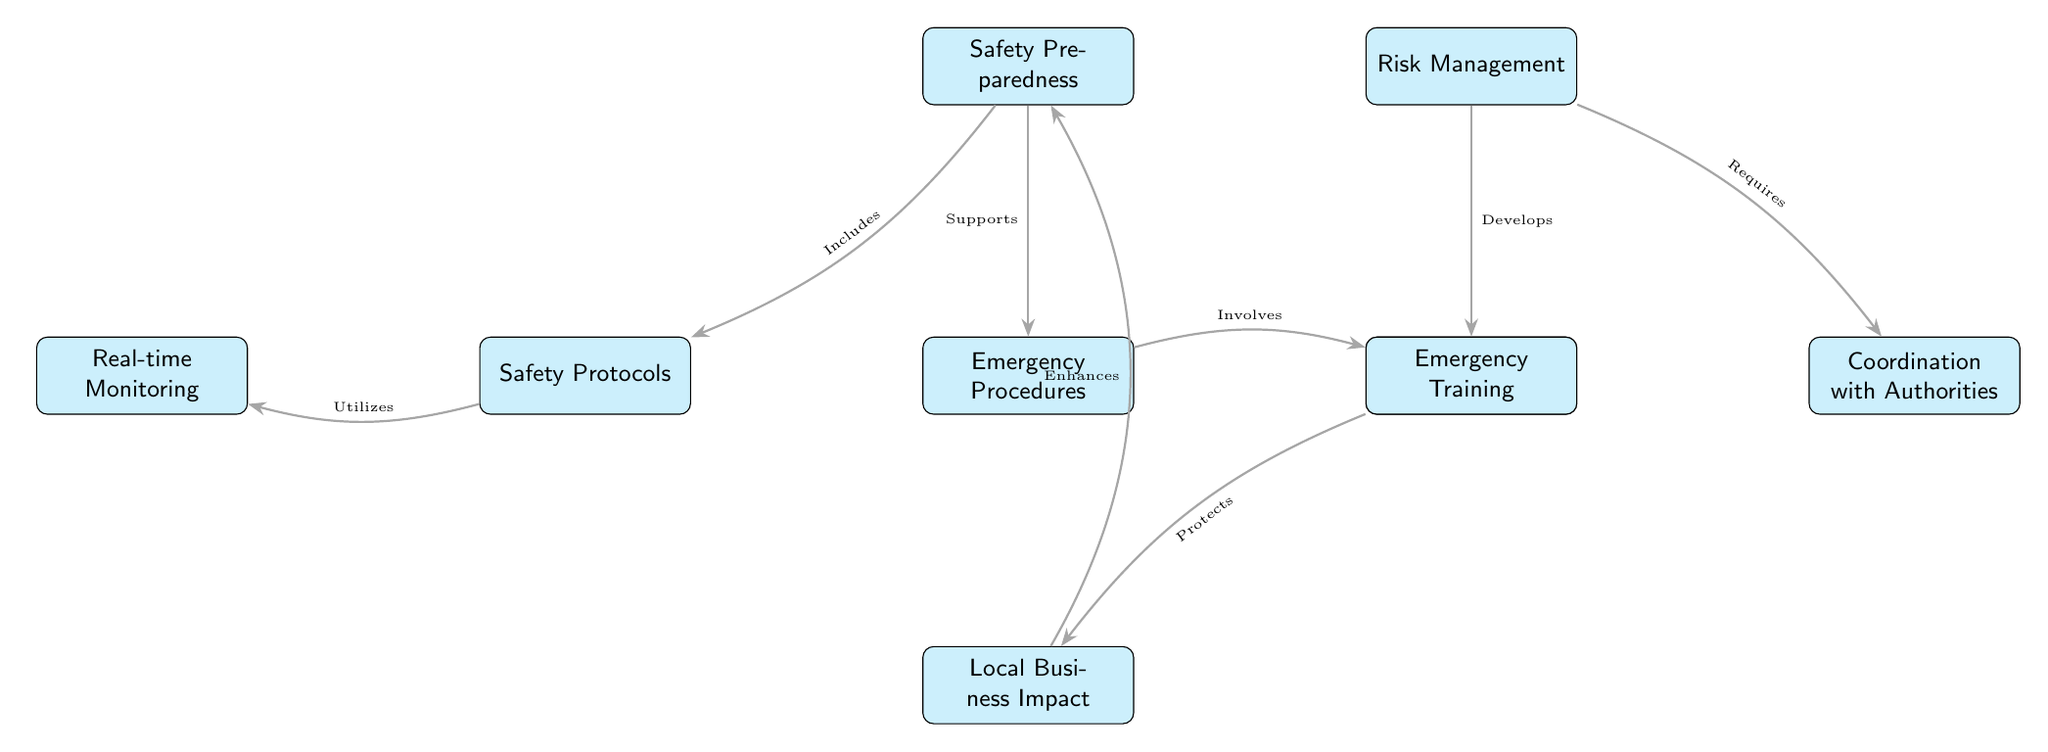What's the total number of nodes in the diagram? Counting the nodes listed in the diagram, we identify a total of 9 distinct nodes.
Answer: 9 What does Safety Preparedness include? The diagram indicates that Safety Preparedness includes Safety Protocols.
Answer: Safety Protocols Which node is directly below Risk Management? The diagram shows that the node positioned directly below Risk Management is Business Continuity Plans.
Answer: Business Continuity Plans What does Emergency Procedures involve? According to the diagram, Emergency Procedures involves Emergency Training.
Answer: Emergency Training How does Local Business Impact relate to Safety Preparedness? The diagram states that Local Business Impact enhances Safety Preparedness, indicating a positive feedback relationship.
Answer: Enhances What relationship exists between Risk Management and Coordination with Authorities? The diagram illustrates that Risk Management requires Coordination with Authorities, which implies a dependent relationship.
Answer: Requires What is the primary function of Business Continuity Plans in the diagram? The diagram indicates that Business Continuity Plans protects Local Business Impact, showing its crucial protective role.
Answer: Protects Which element has a direct flow leading to Emergency Training? Following the arrows in the diagram, it shows that Emergency Procedures has a direct flow leading to Emergency Training.
Answer: Emergency Procedures How are Safety Protocols and Real-time Monitoring related? The diagram indicates that Safety Protocols utilize Real-time Monitoring, establishing a supportive relationship between the two.
Answer: Utilizes 